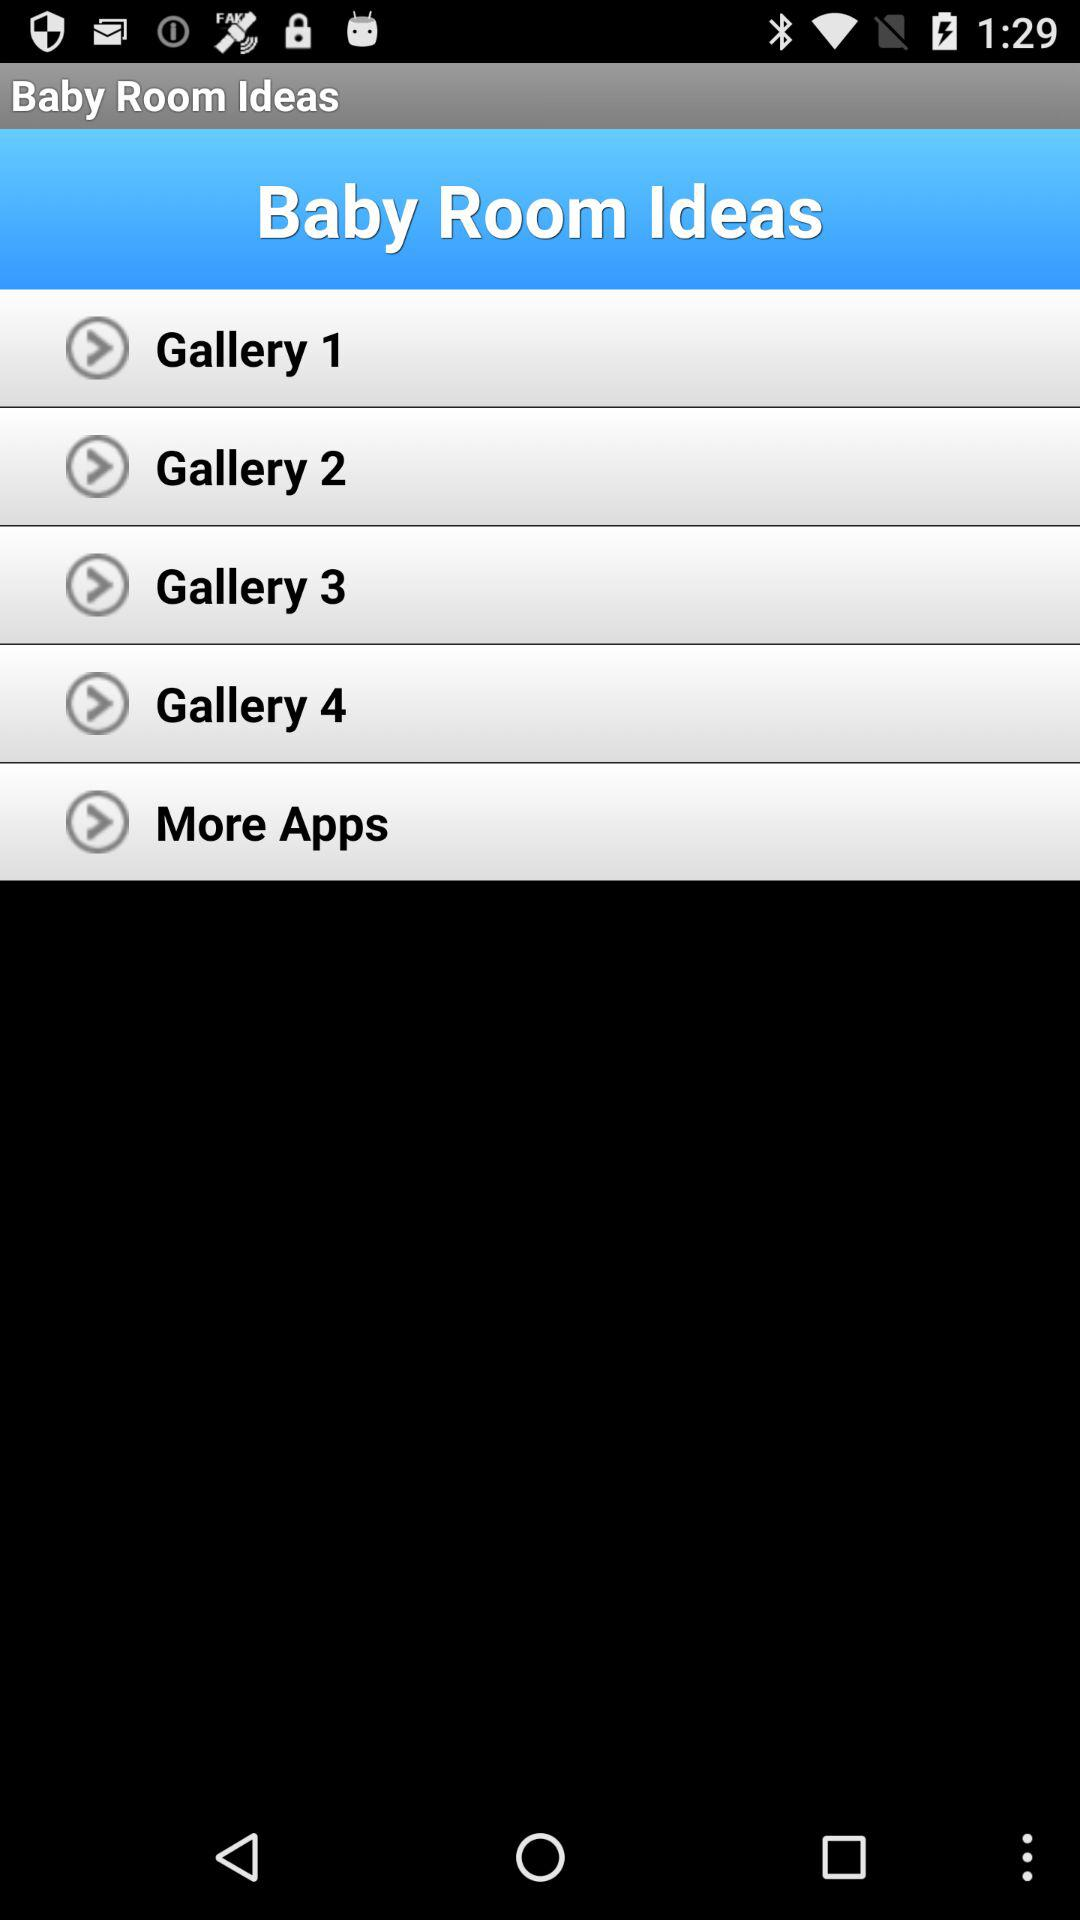How many galleries are there?
Answer the question using a single word or phrase. 4 